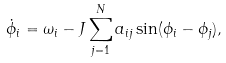<formula> <loc_0><loc_0><loc_500><loc_500>\dot { \phi } _ { i } = \omega _ { i } - J \sum _ { j = 1 } ^ { N } a _ { i j } \sin ( \phi _ { i } - \phi _ { j } ) ,</formula> 